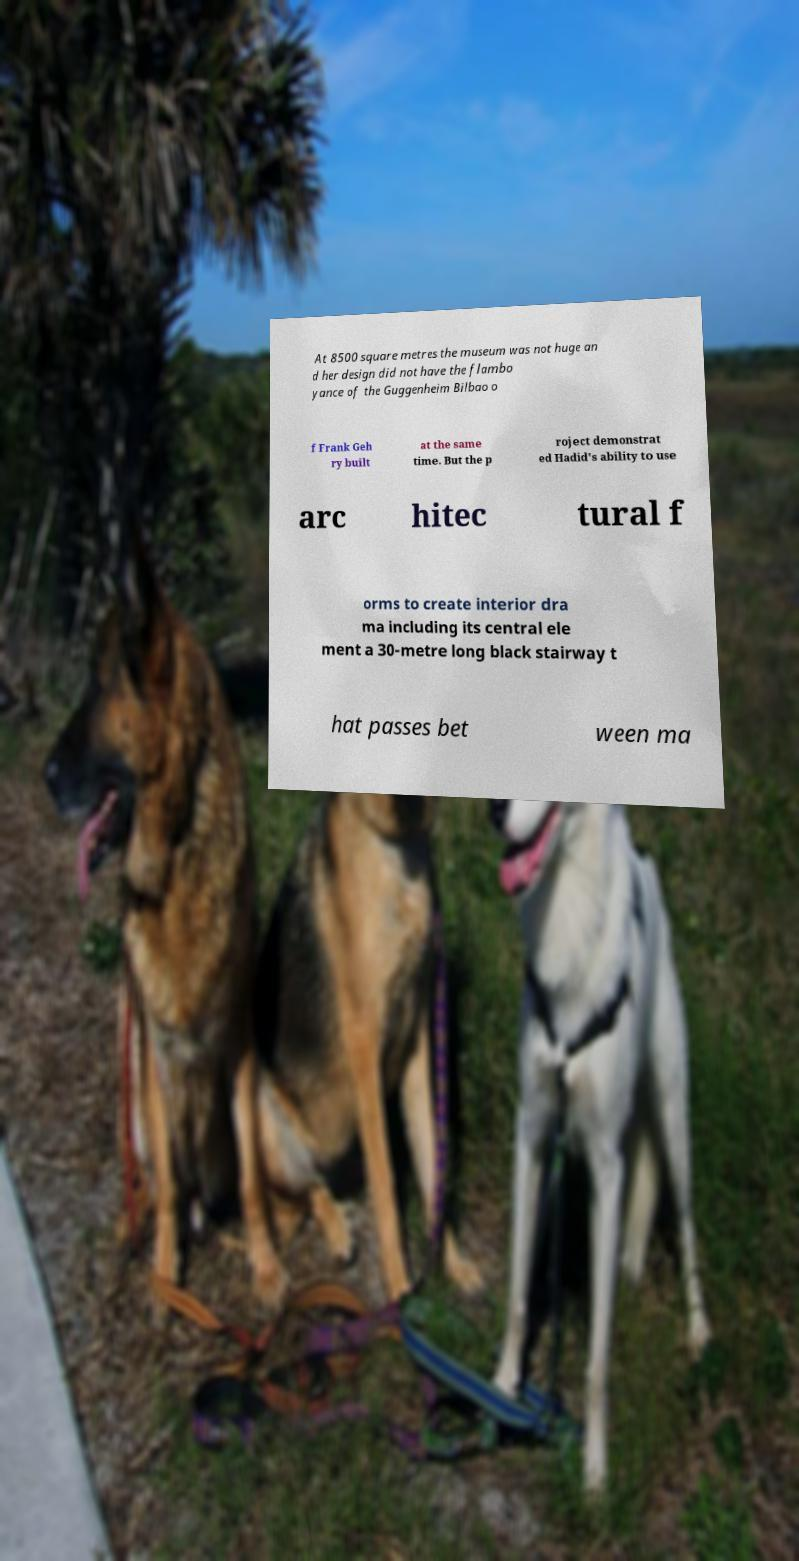Can you read and provide the text displayed in the image?This photo seems to have some interesting text. Can you extract and type it out for me? At 8500 square metres the museum was not huge an d her design did not have the flambo yance of the Guggenheim Bilbao o f Frank Geh ry built at the same time. But the p roject demonstrat ed Hadid's ability to use arc hitec tural f orms to create interior dra ma including its central ele ment a 30-metre long black stairway t hat passes bet ween ma 